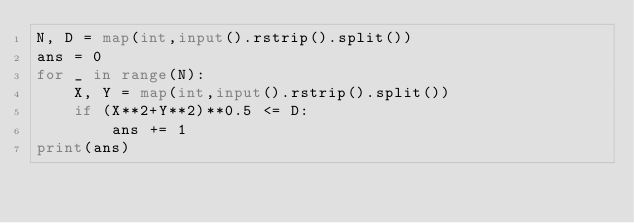<code> <loc_0><loc_0><loc_500><loc_500><_Python_>N, D = map(int,input().rstrip().split())
ans = 0
for _ in range(N):
    X, Y = map(int,input().rstrip().split())
    if (X**2+Y**2)**0.5 <= D:
        ans += 1
print(ans)</code> 